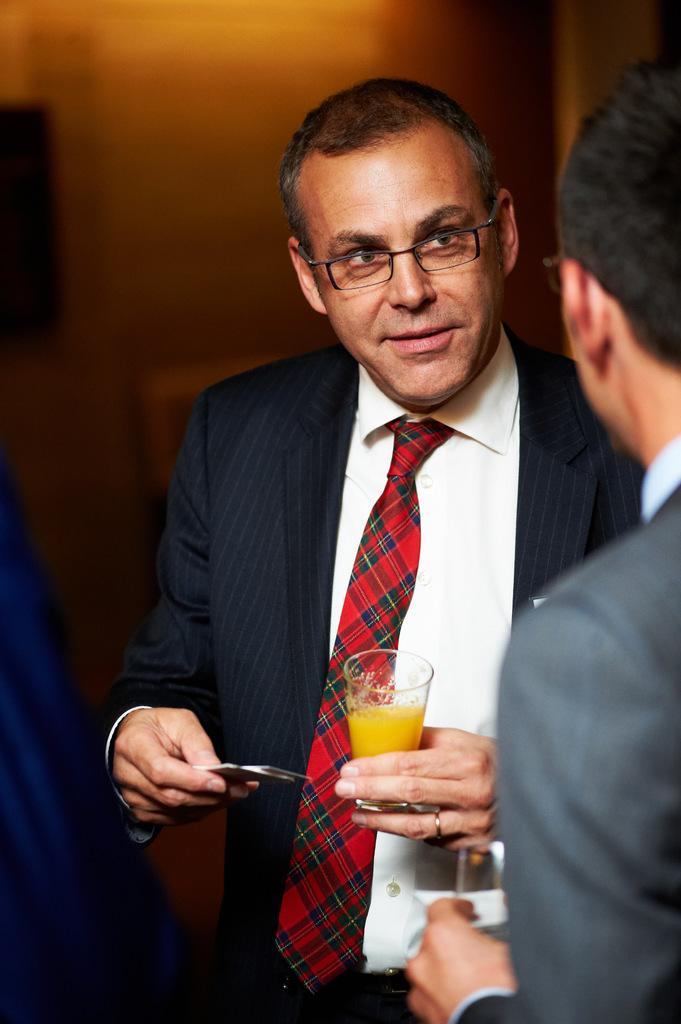How many people are in the image? There are two men in the image. What are the men doing in the image? Both men are standing in the image. What objects are the men holding in their hands? Both men are holding glasses in their hands. Can you describe any accessories the men are wearing? One of the men is wearing spectacles, and another man is wearing a finger ring. What can be observed about the lighting in the image? The background of the image is slightly dark. What type of fruit is being discussed in the meeting depicted in the image? There is no meeting depicted in the image, and no fruit is present or being discussed. 